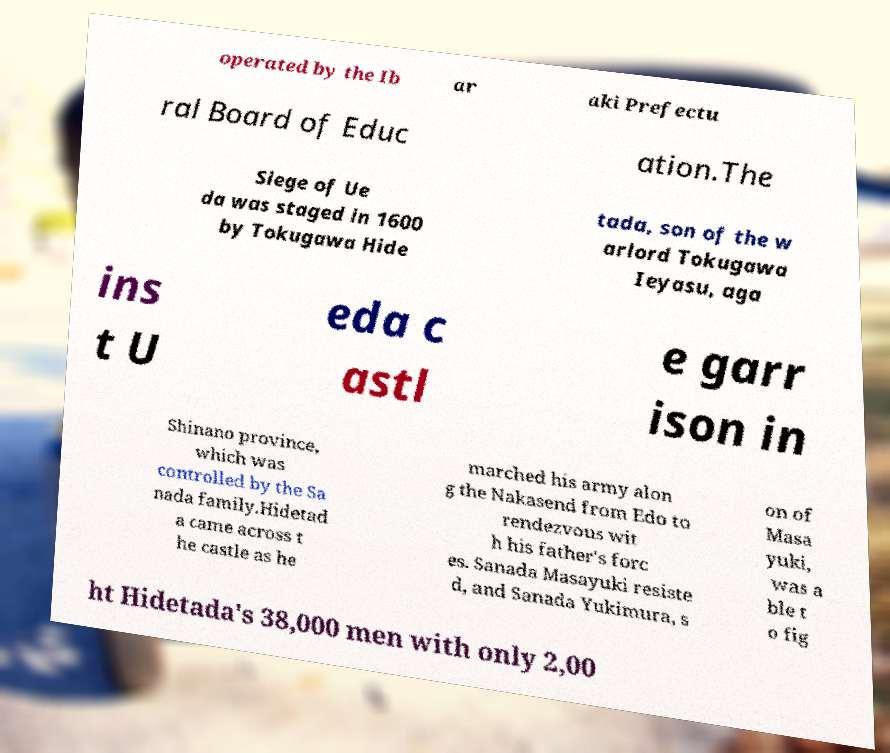Could you assist in decoding the text presented in this image and type it out clearly? operated by the Ib ar aki Prefectu ral Board of Educ ation.The Siege of Ue da was staged in 1600 by Tokugawa Hide tada, son of the w arlord Tokugawa Ieyasu, aga ins t U eda c astl e garr ison in Shinano province, which was controlled by the Sa nada family.Hidetad a came across t he castle as he marched his army alon g the Nakasend from Edo to rendezvous wit h his father's forc es. Sanada Masayuki resiste d, and Sanada Yukimura, s on of Masa yuki, was a ble t o fig ht Hidetada's 38,000 men with only 2,00 